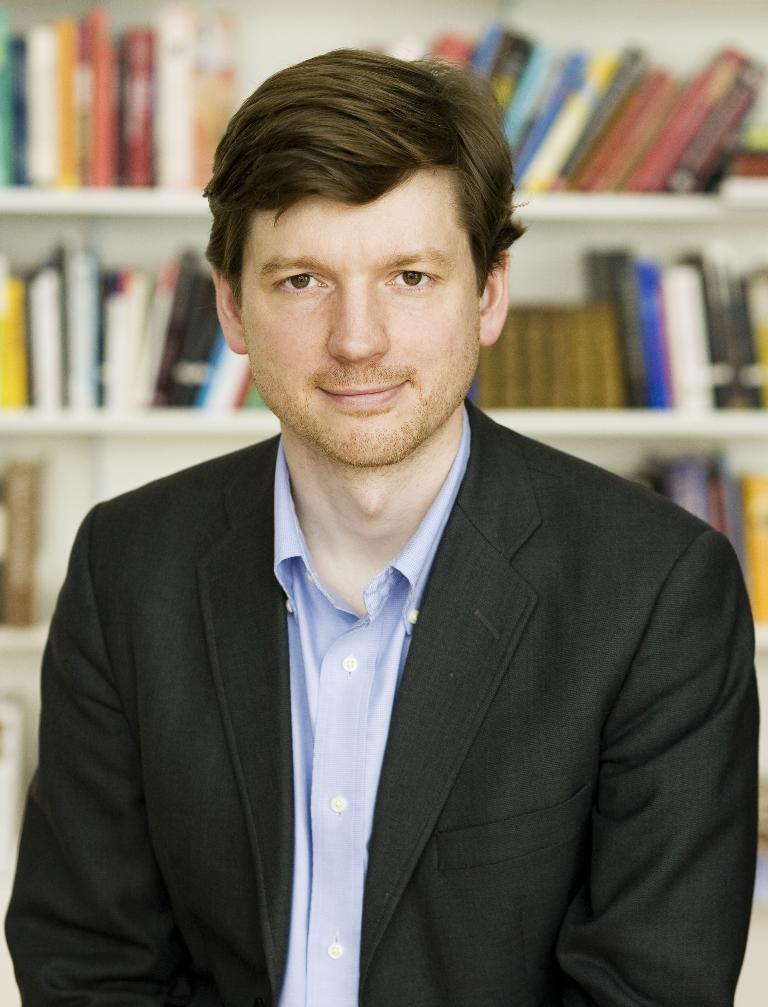How would you summarize this image in a sentence or two? In this image, there is a person in front of the rack contains some books. 